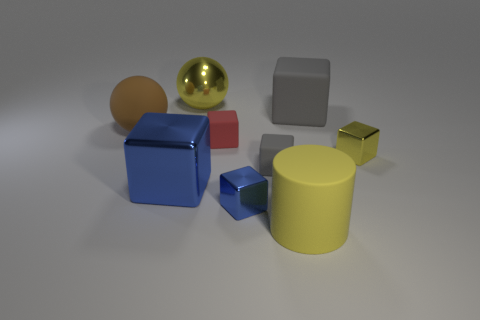Subtract 1 cubes. How many cubes are left? 5 Subtract all gray blocks. How many blocks are left? 4 Subtract all red blocks. How many blocks are left? 5 Subtract all purple cylinders. Subtract all gray cubes. How many cylinders are left? 1 Subtract all spheres. How many objects are left? 7 Add 5 tiny blocks. How many tiny blocks exist? 9 Subtract 1 yellow blocks. How many objects are left? 8 Subtract all tiny blue matte cylinders. Subtract all yellow rubber cylinders. How many objects are left? 8 Add 2 small blue blocks. How many small blue blocks are left? 3 